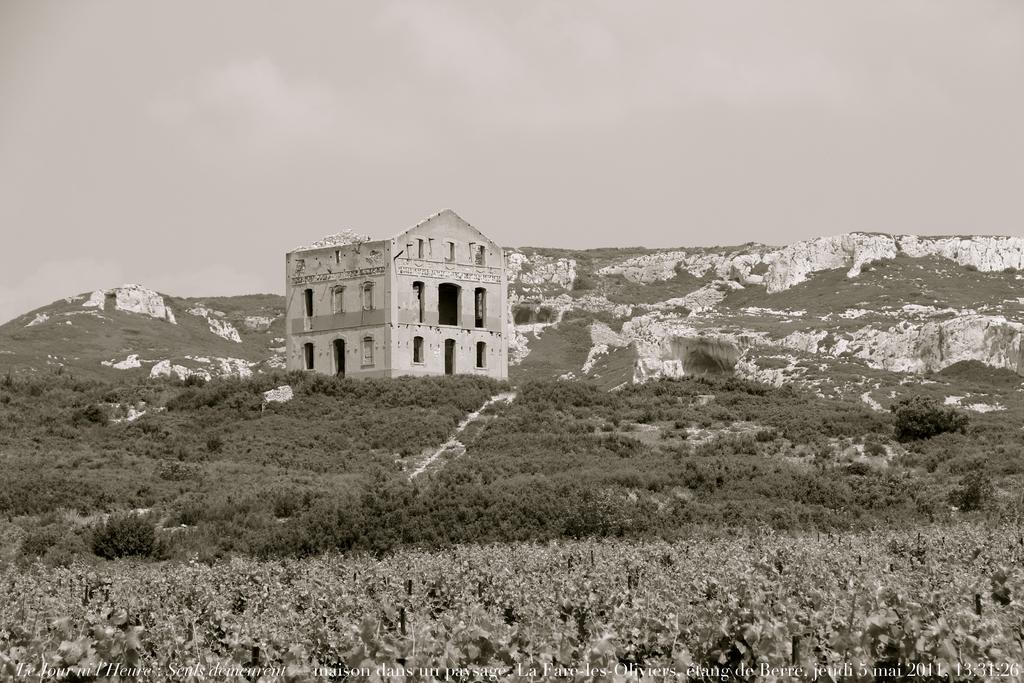What type of vegetation can be seen in the image? There are trees in the image. What type of structure is present in the image? There is a building in the image. What can be seen in the distance in the image? Mountains are visible in the background of the image. What is visible above the trees and building in the image? The sky is visible in the background of the image. What is the cause of the horse's shock in the image? There is no horse present in the image, so there is no shock to be caused. 